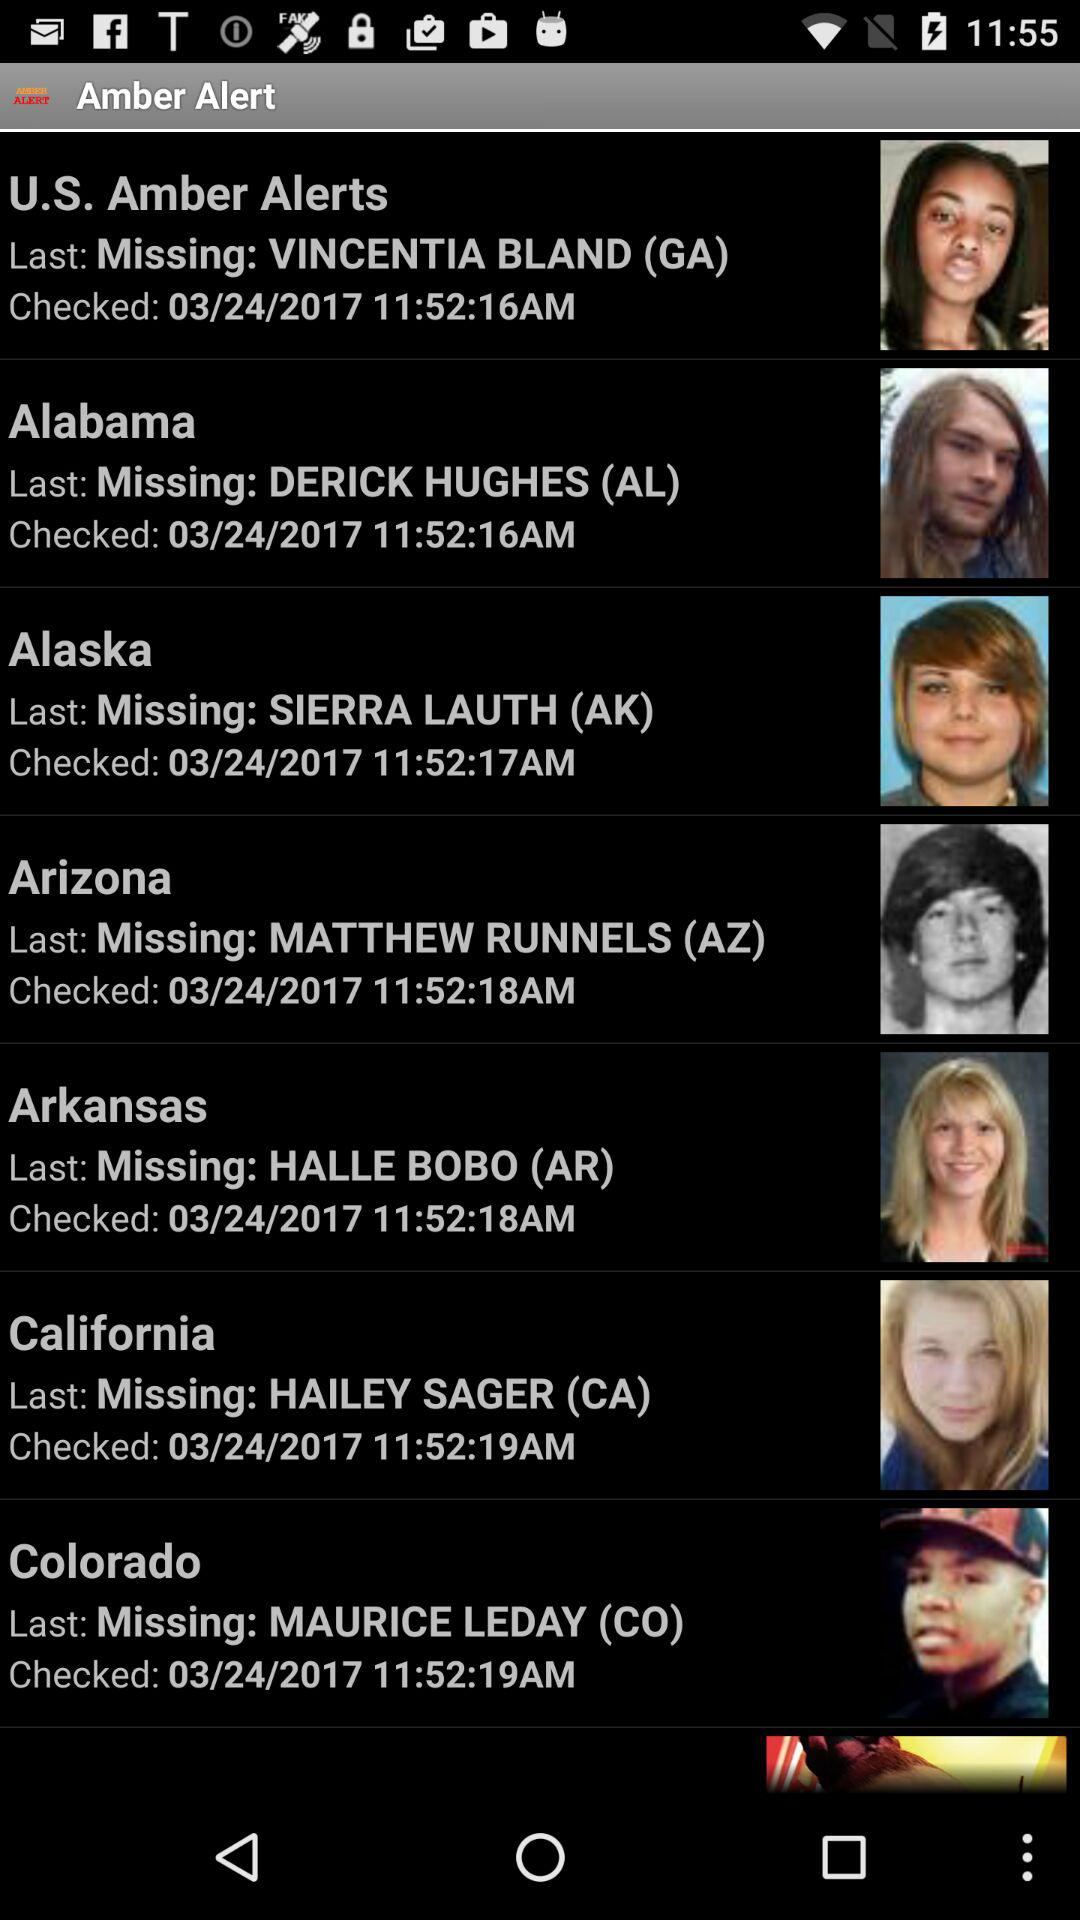What is the address of Hailey Sager? The address of Hailey Sager is California. 